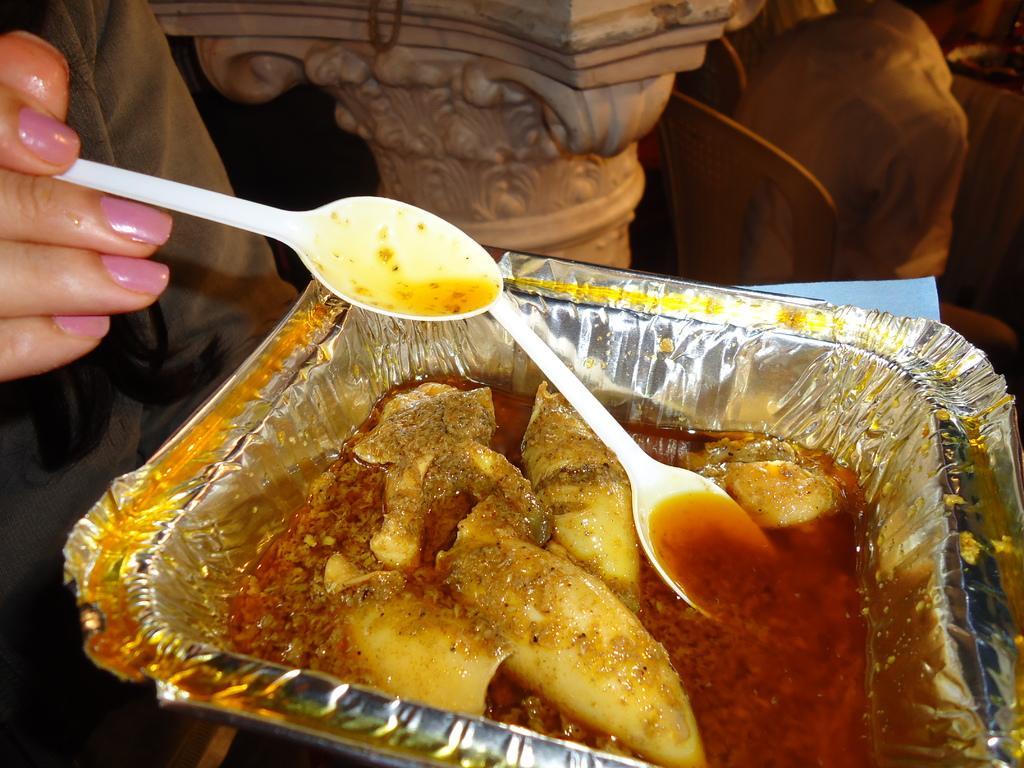How would you summarize this image in a sentence or two? In this picture we can see a food item in aluminium foil box. There is a white color spoon in that box. The lady is holding white color spoon in her hands. she is having a pink color nail polish on her hands. In the middle there is a pole or a pillar. To the right side top corner where we can see a person Sitting on a chair. 